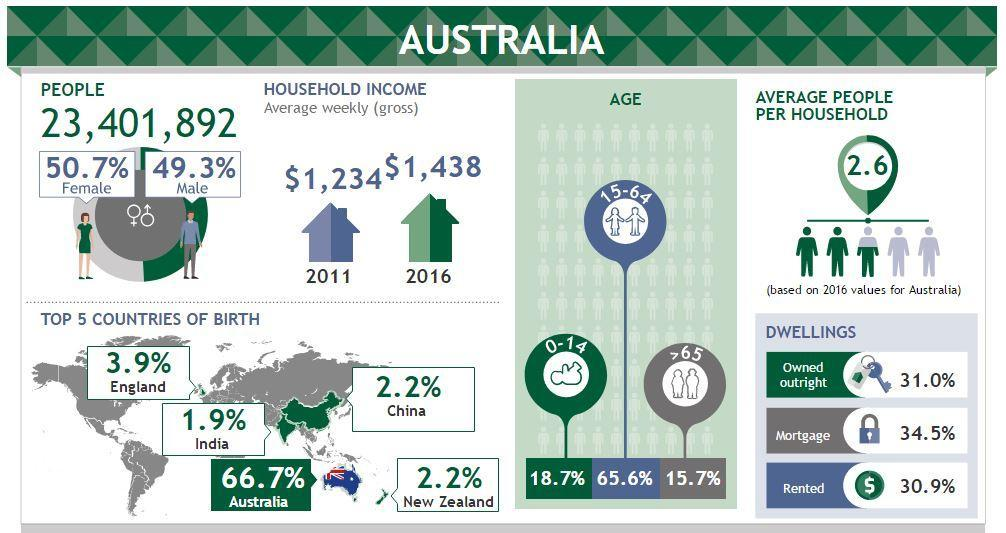Which age group forms the most people in Australia?
Answer the question with a short phrase. 15-64 What percent of people are senior citizens? 15.7% Which gender is slightly more in Australia? Female By what percent is males less than females in number? 1.4% Which dwelling is most common? Mortgage What percent of Chinese reside in Australia? 2.2% 